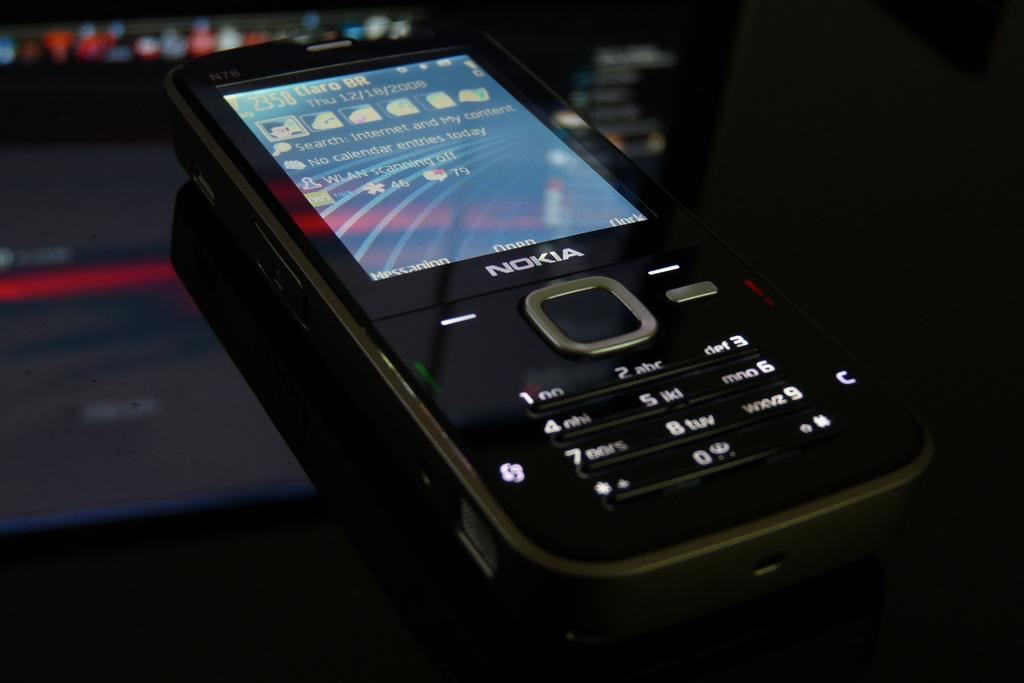<image>
Create a compact narrative representing the image presented. A black Nokia phone laying on a dark colored background. 